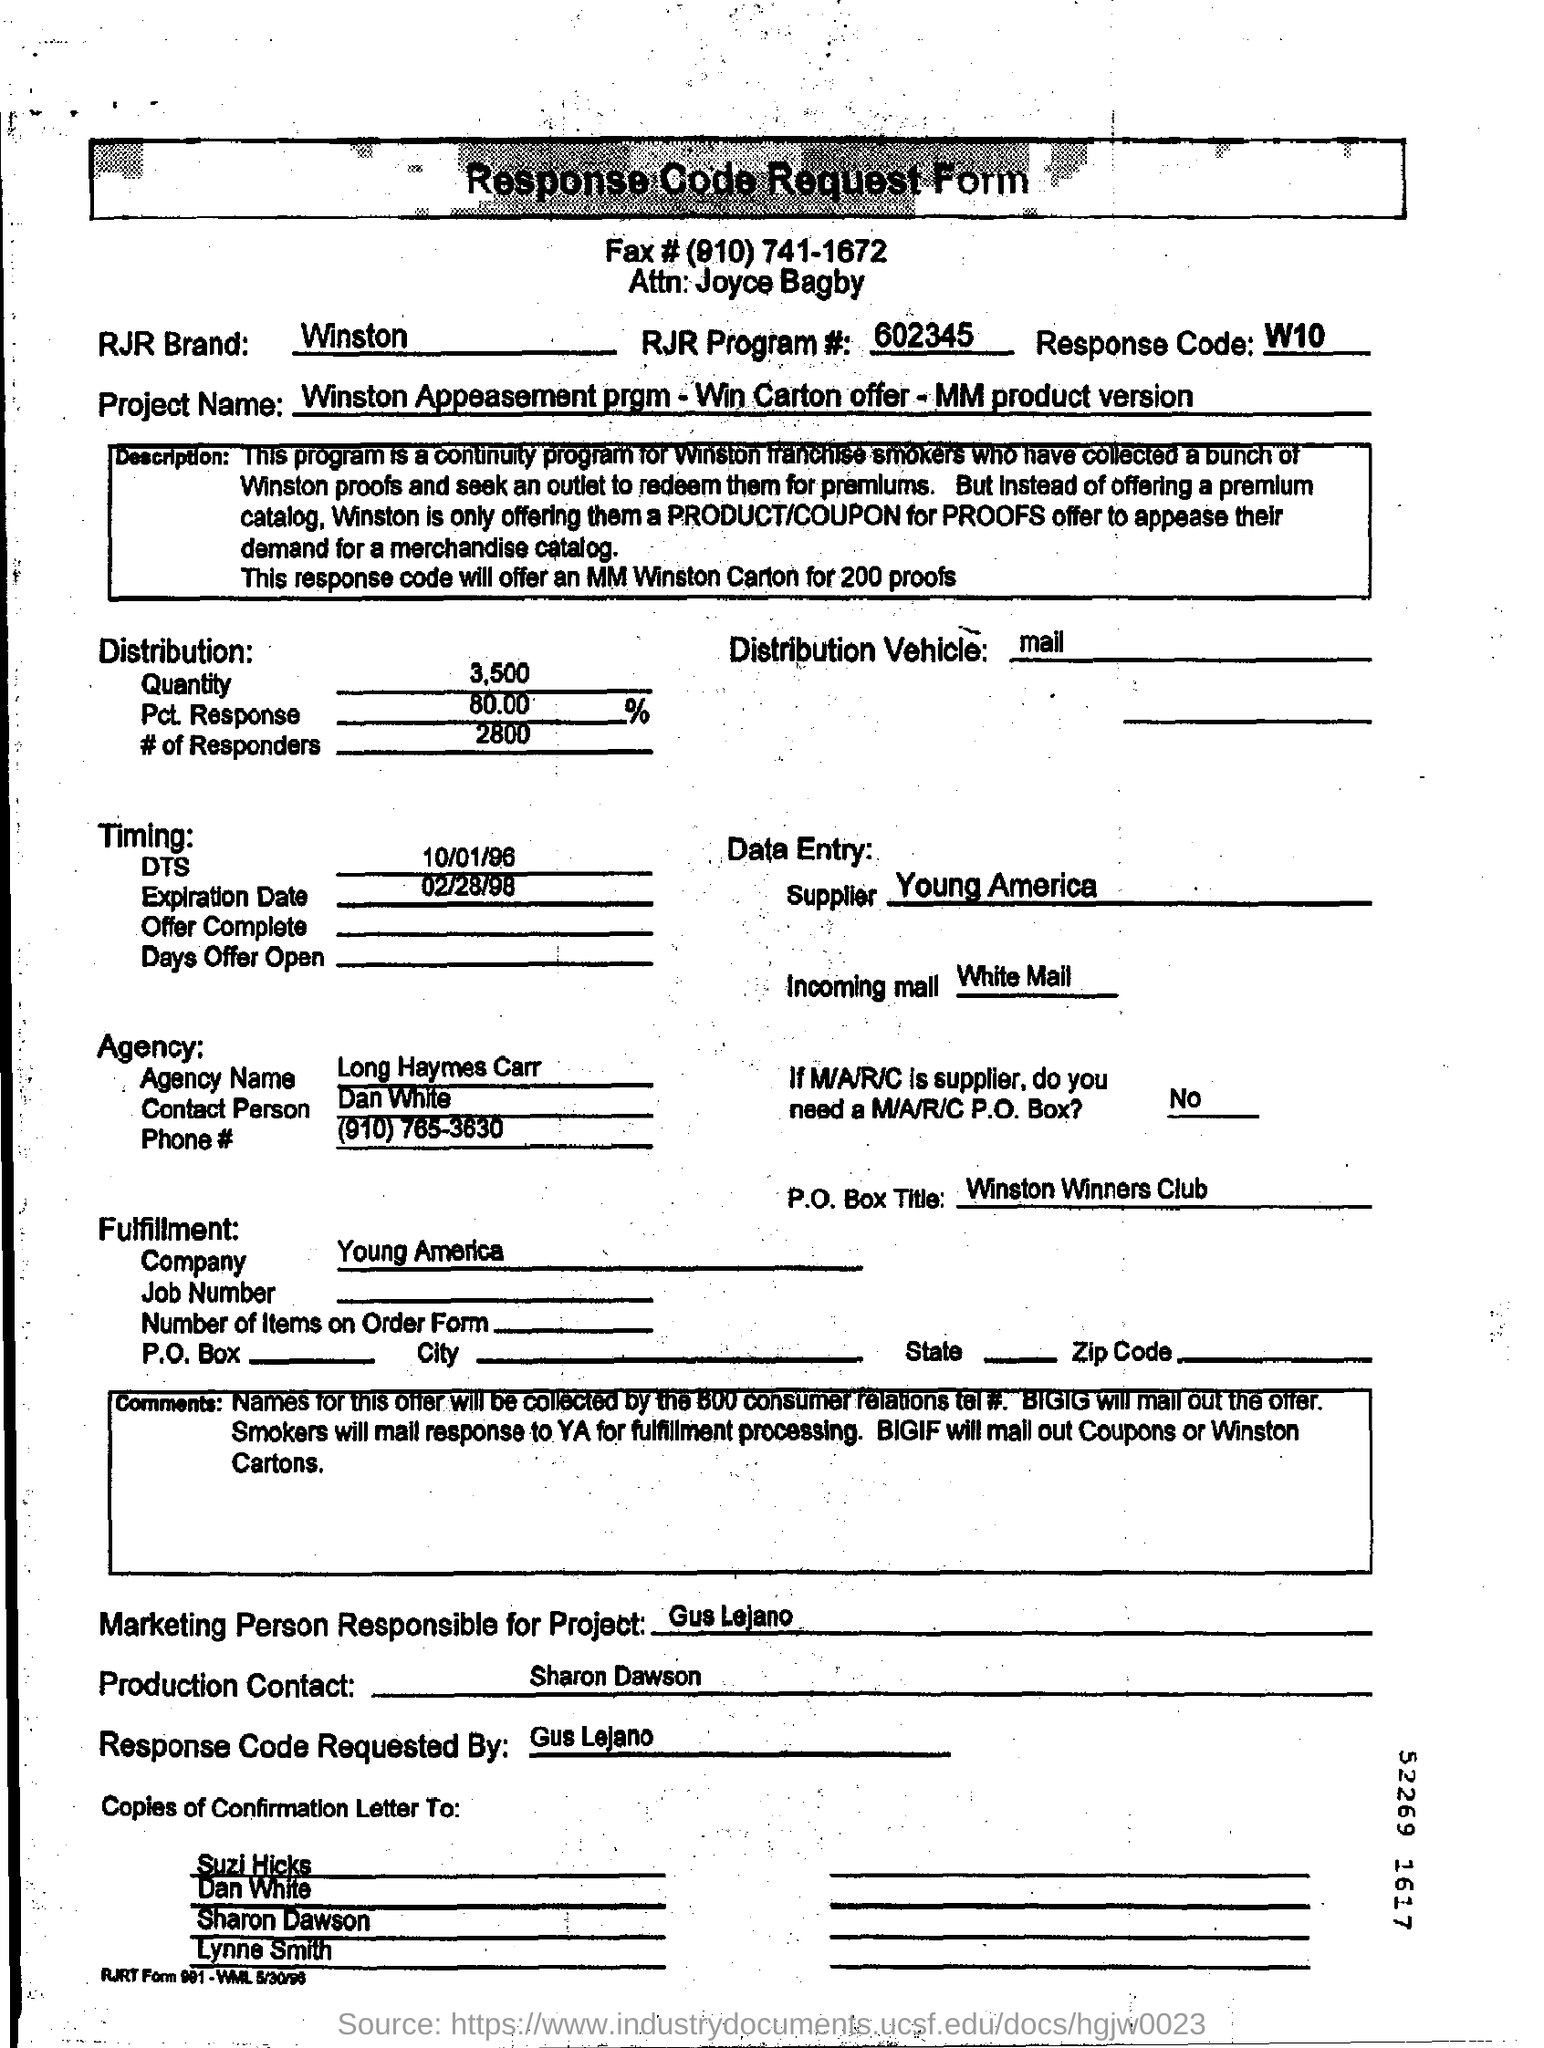Mention a couple of crucial points in this snapshot. The RJR Program Number is 602345... The P.O.Box title field contains the words 'Winston Winners Club.' The document's title is 'Response Code Request Form.' The supplier is Young America. The date mentioned in the DTS field is 10/01/96. 